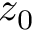<formula> <loc_0><loc_0><loc_500><loc_500>z _ { 0 }</formula> 